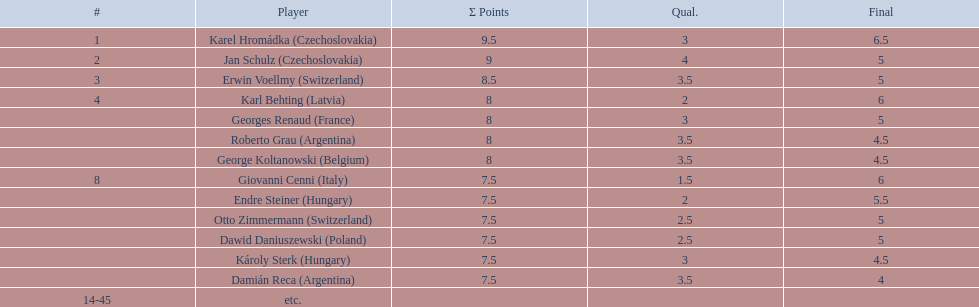Who was the player with the most points scored? Karel Hromádka. 